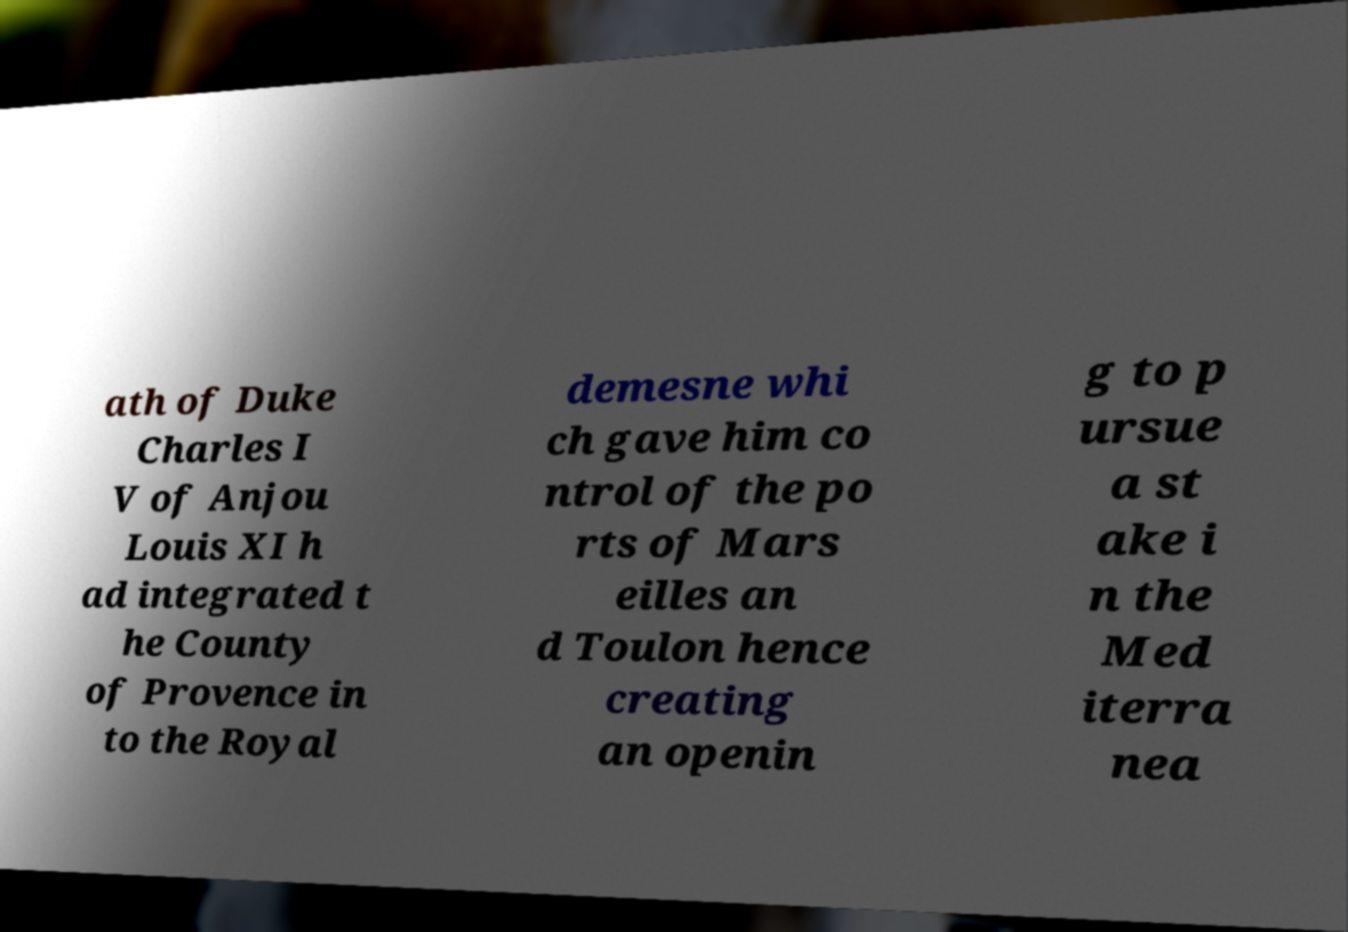Can you read and provide the text displayed in the image?This photo seems to have some interesting text. Can you extract and type it out for me? ath of Duke Charles I V of Anjou Louis XI h ad integrated t he County of Provence in to the Royal demesne whi ch gave him co ntrol of the po rts of Mars eilles an d Toulon hence creating an openin g to p ursue a st ake i n the Med iterra nea 